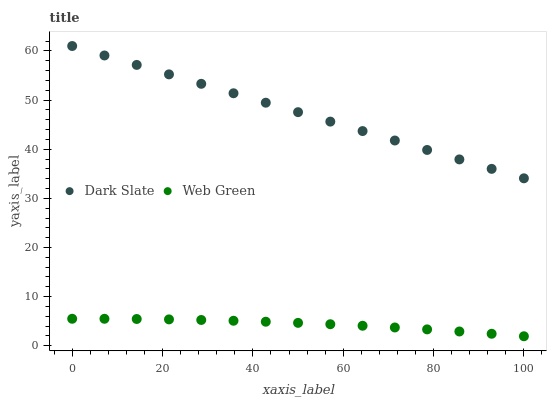Does Web Green have the minimum area under the curve?
Answer yes or no. Yes. Does Dark Slate have the maximum area under the curve?
Answer yes or no. Yes. Does Web Green have the maximum area under the curve?
Answer yes or no. No. Is Dark Slate the smoothest?
Answer yes or no. Yes. Is Web Green the roughest?
Answer yes or no. Yes. Is Web Green the smoothest?
Answer yes or no. No. Does Web Green have the lowest value?
Answer yes or no. Yes. Does Dark Slate have the highest value?
Answer yes or no. Yes. Does Web Green have the highest value?
Answer yes or no. No. Is Web Green less than Dark Slate?
Answer yes or no. Yes. Is Dark Slate greater than Web Green?
Answer yes or no. Yes. Does Web Green intersect Dark Slate?
Answer yes or no. No. 